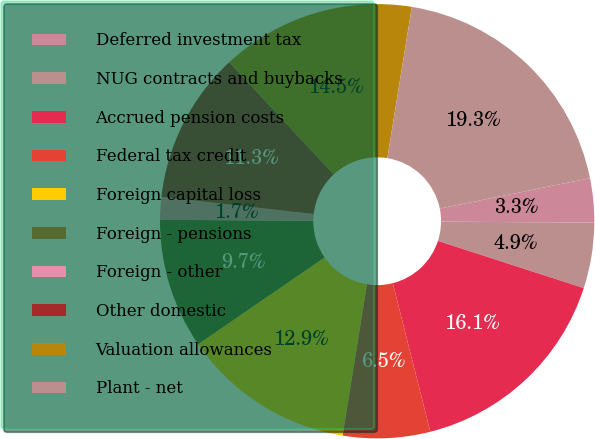Convert chart. <chart><loc_0><loc_0><loc_500><loc_500><pie_chart><fcel>Deferred investment tax<fcel>NUG contracts and buybacks<fcel>Accrued pension costs<fcel>Federal tax credit<fcel>Foreign capital loss<fcel>Foreign - pensions<fcel>Foreign - other<fcel>Other domestic<fcel>Valuation allowances<fcel>Plant - net<nl><fcel>3.28%<fcel>4.88%<fcel>16.08%<fcel>6.48%<fcel>12.88%<fcel>9.68%<fcel>1.69%<fcel>11.28%<fcel>14.48%<fcel>19.27%<nl></chart> 